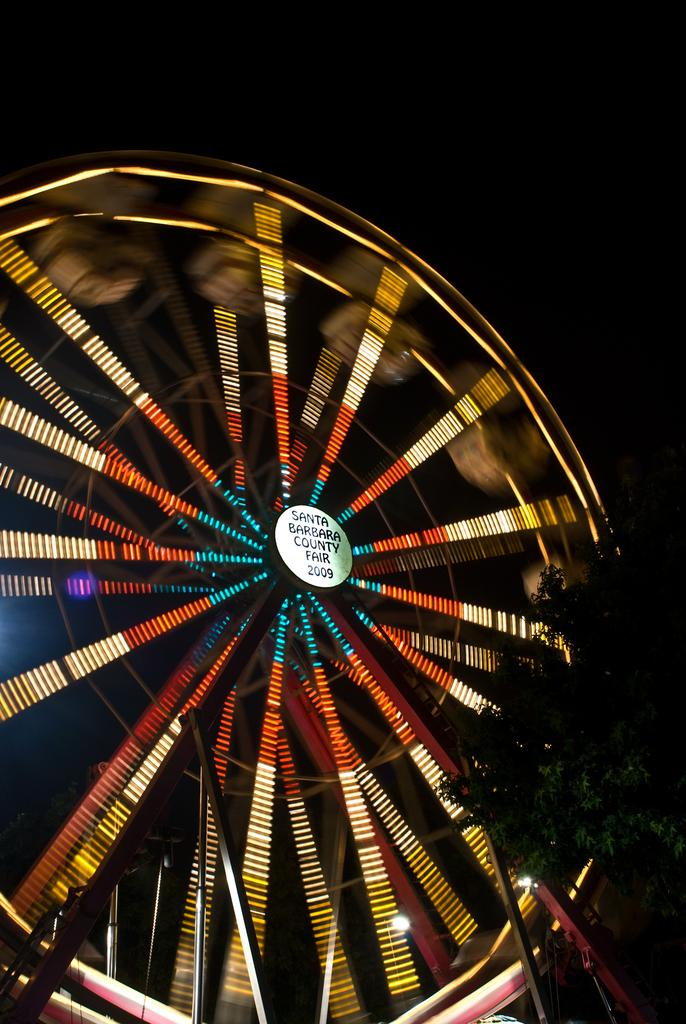What is the main feature of the image? There is a giant wheel with lights in the image. What else can be seen in the image besides the giant wheel? There is a board and a tree on the right side of the image. What type of flowers are growing on the giant wheel in the image? There are no flowers present on the giant wheel in the image. 